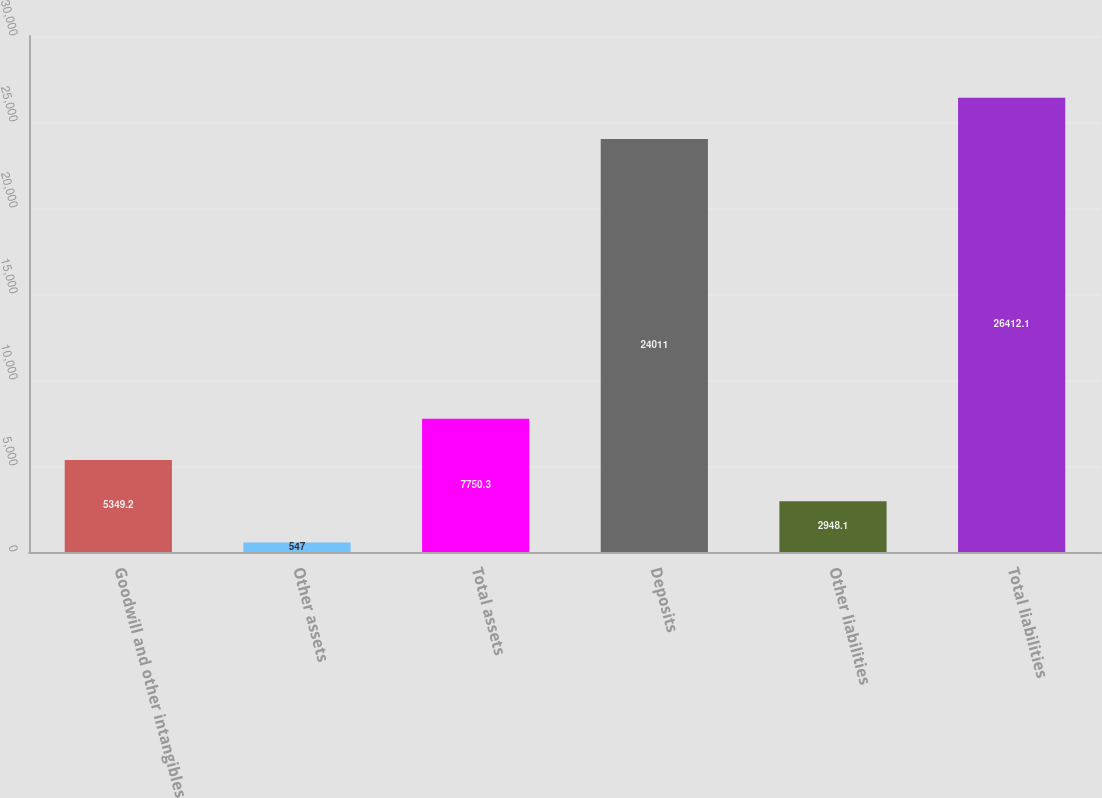<chart> <loc_0><loc_0><loc_500><loc_500><bar_chart><fcel>Goodwill and other intangibles<fcel>Other assets<fcel>Total assets<fcel>Deposits<fcel>Other liabilities<fcel>Total liabilities<nl><fcel>5349.2<fcel>547<fcel>7750.3<fcel>24011<fcel>2948.1<fcel>26412.1<nl></chart> 